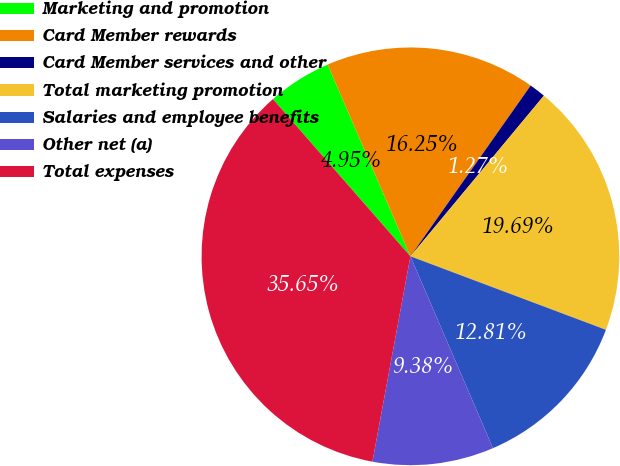<chart> <loc_0><loc_0><loc_500><loc_500><pie_chart><fcel>Marketing and promotion<fcel>Card Member rewards<fcel>Card Member services and other<fcel>Total marketing promotion<fcel>Salaries and employee benefits<fcel>Other net (a)<fcel>Total expenses<nl><fcel>4.95%<fcel>16.25%<fcel>1.27%<fcel>19.69%<fcel>12.81%<fcel>9.38%<fcel>35.65%<nl></chart> 